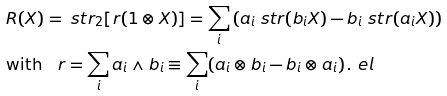<formula> <loc_0><loc_0><loc_500><loc_500>& R ( X ) = \ s t r _ { 2 } [ r ( 1 \otimes X ) ] = \sum _ { i } \left ( a _ { i } \ s t r ( b _ { i } X ) - b _ { i } \ s t r ( a _ { i } X ) \right ) \\ & \text {with} \quad r = \sum _ { i } a _ { i } \wedge b _ { i } \equiv \sum _ { i } ( a _ { i } \otimes b _ { i } - b _ { i } \otimes a _ { i } ) \, . \ e l</formula> 